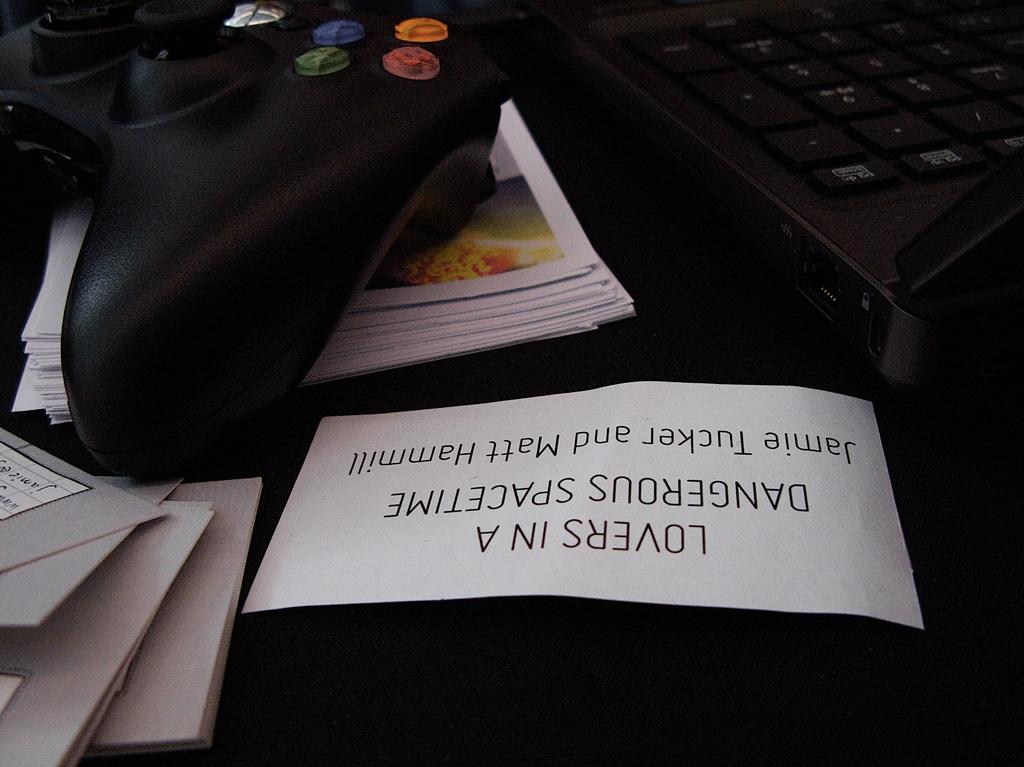Is this by jamie tucker?
Make the answer very short. Yes. What title is written on the white tag?
Make the answer very short. Lovers in a dangerous spacetime. 